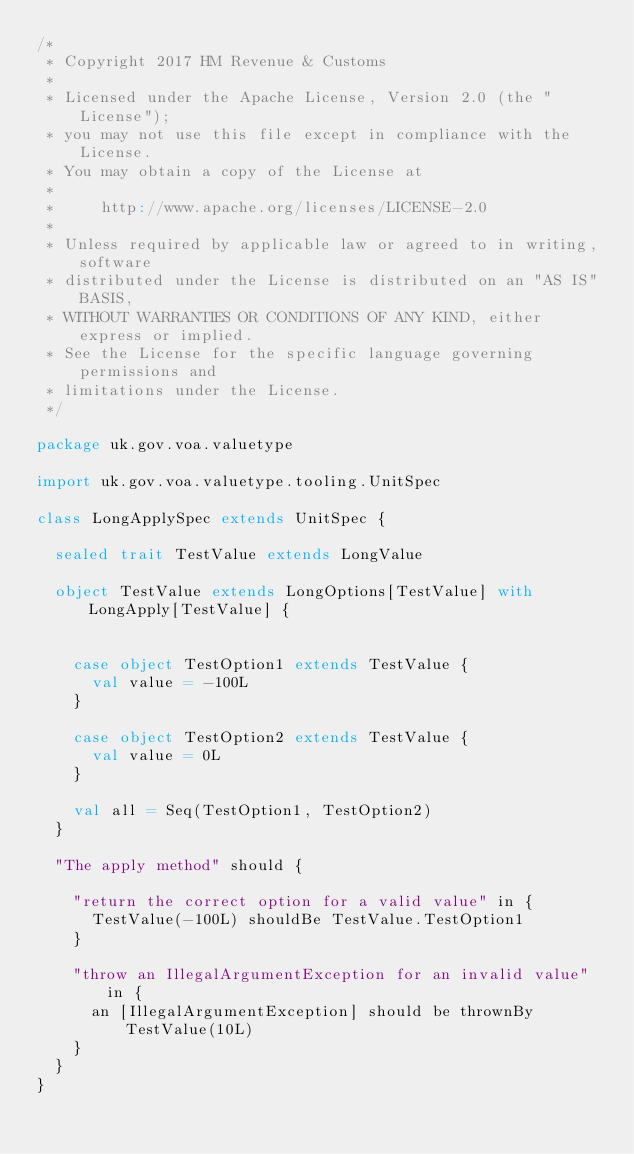Convert code to text. <code><loc_0><loc_0><loc_500><loc_500><_Scala_>/*
 * Copyright 2017 HM Revenue & Customs
 *
 * Licensed under the Apache License, Version 2.0 (the "License");
 * you may not use this file except in compliance with the License.
 * You may obtain a copy of the License at
 *
 *     http://www.apache.org/licenses/LICENSE-2.0
 *
 * Unless required by applicable law or agreed to in writing, software
 * distributed under the License is distributed on an "AS IS" BASIS,
 * WITHOUT WARRANTIES OR CONDITIONS OF ANY KIND, either express or implied.
 * See the License for the specific language governing permissions and
 * limitations under the License.
 */

package uk.gov.voa.valuetype

import uk.gov.voa.valuetype.tooling.UnitSpec

class LongApplySpec extends UnitSpec {

  sealed trait TestValue extends LongValue

  object TestValue extends LongOptions[TestValue] with LongApply[TestValue] {


    case object TestOption1 extends TestValue {
      val value = -100L
    }

    case object TestOption2 extends TestValue {
      val value = 0L
    }

    val all = Seq(TestOption1, TestOption2)
  }

  "The apply method" should {

    "return the correct option for a valid value" in {
      TestValue(-100L) shouldBe TestValue.TestOption1
    }

    "throw an IllegalArgumentException for an invalid value" in {
      an [IllegalArgumentException] should be thrownBy TestValue(10L)
    }
  }
}
</code> 